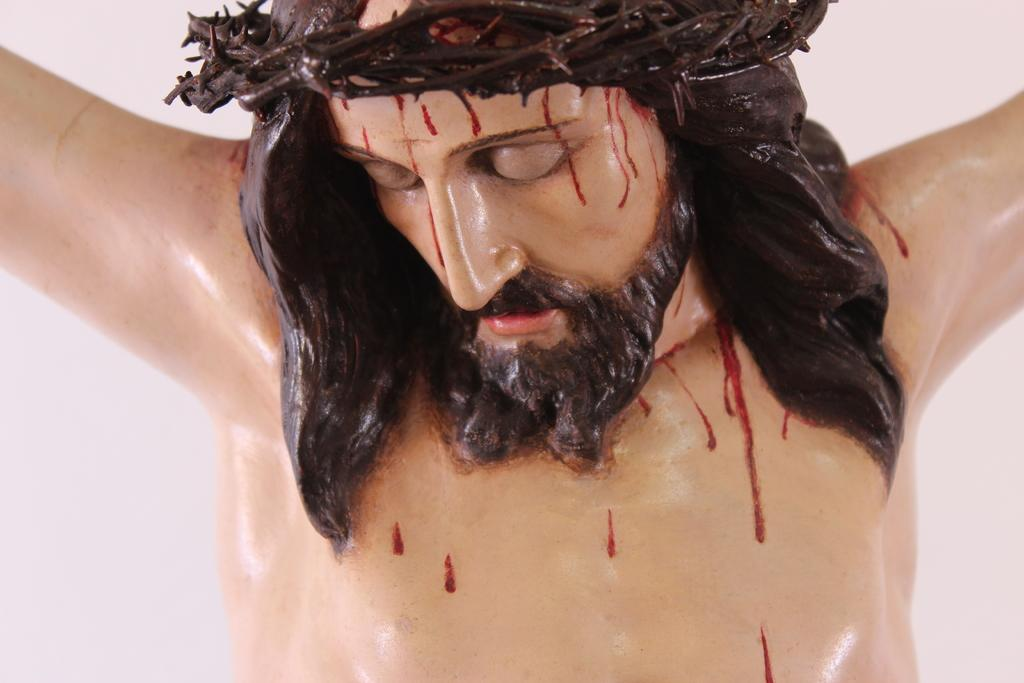What is the main subject of the image? There is a statue in the image. What can be seen in the background of the image? The background of the image is white. What type of feet can be seen on the statue in the image? There is no mention of feet or any specific details about the statue in the image, so it cannot be determined from the provided facts. 